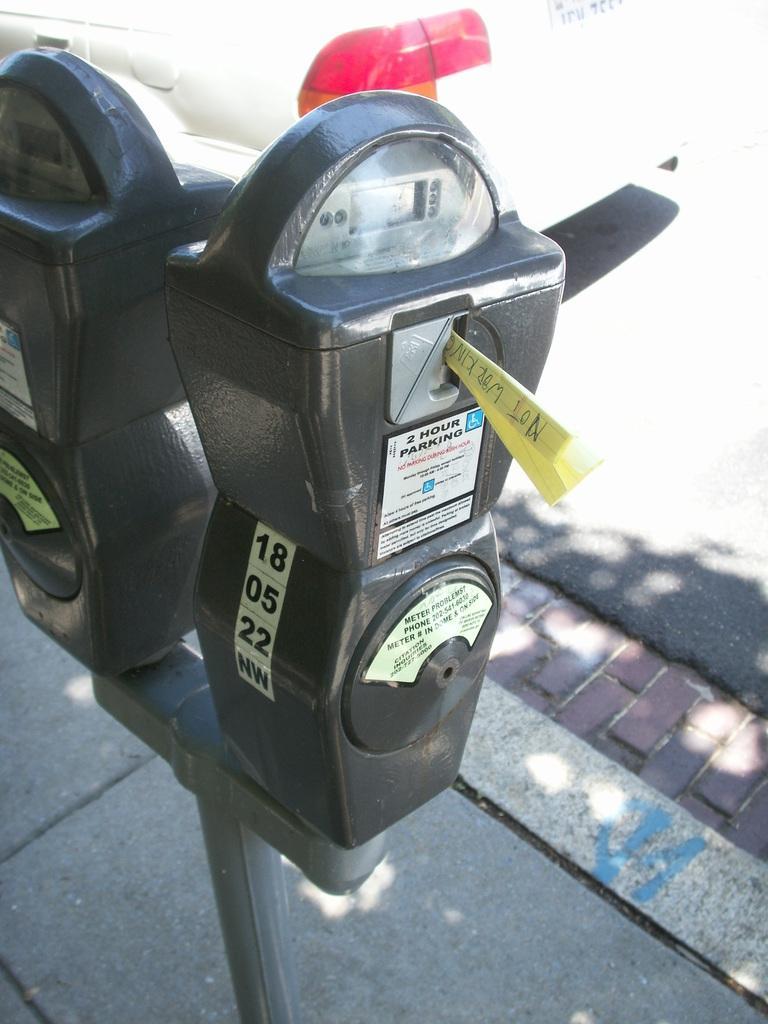Please provide a concise description of this image. In the image there are two parking meters kept beside the road. 